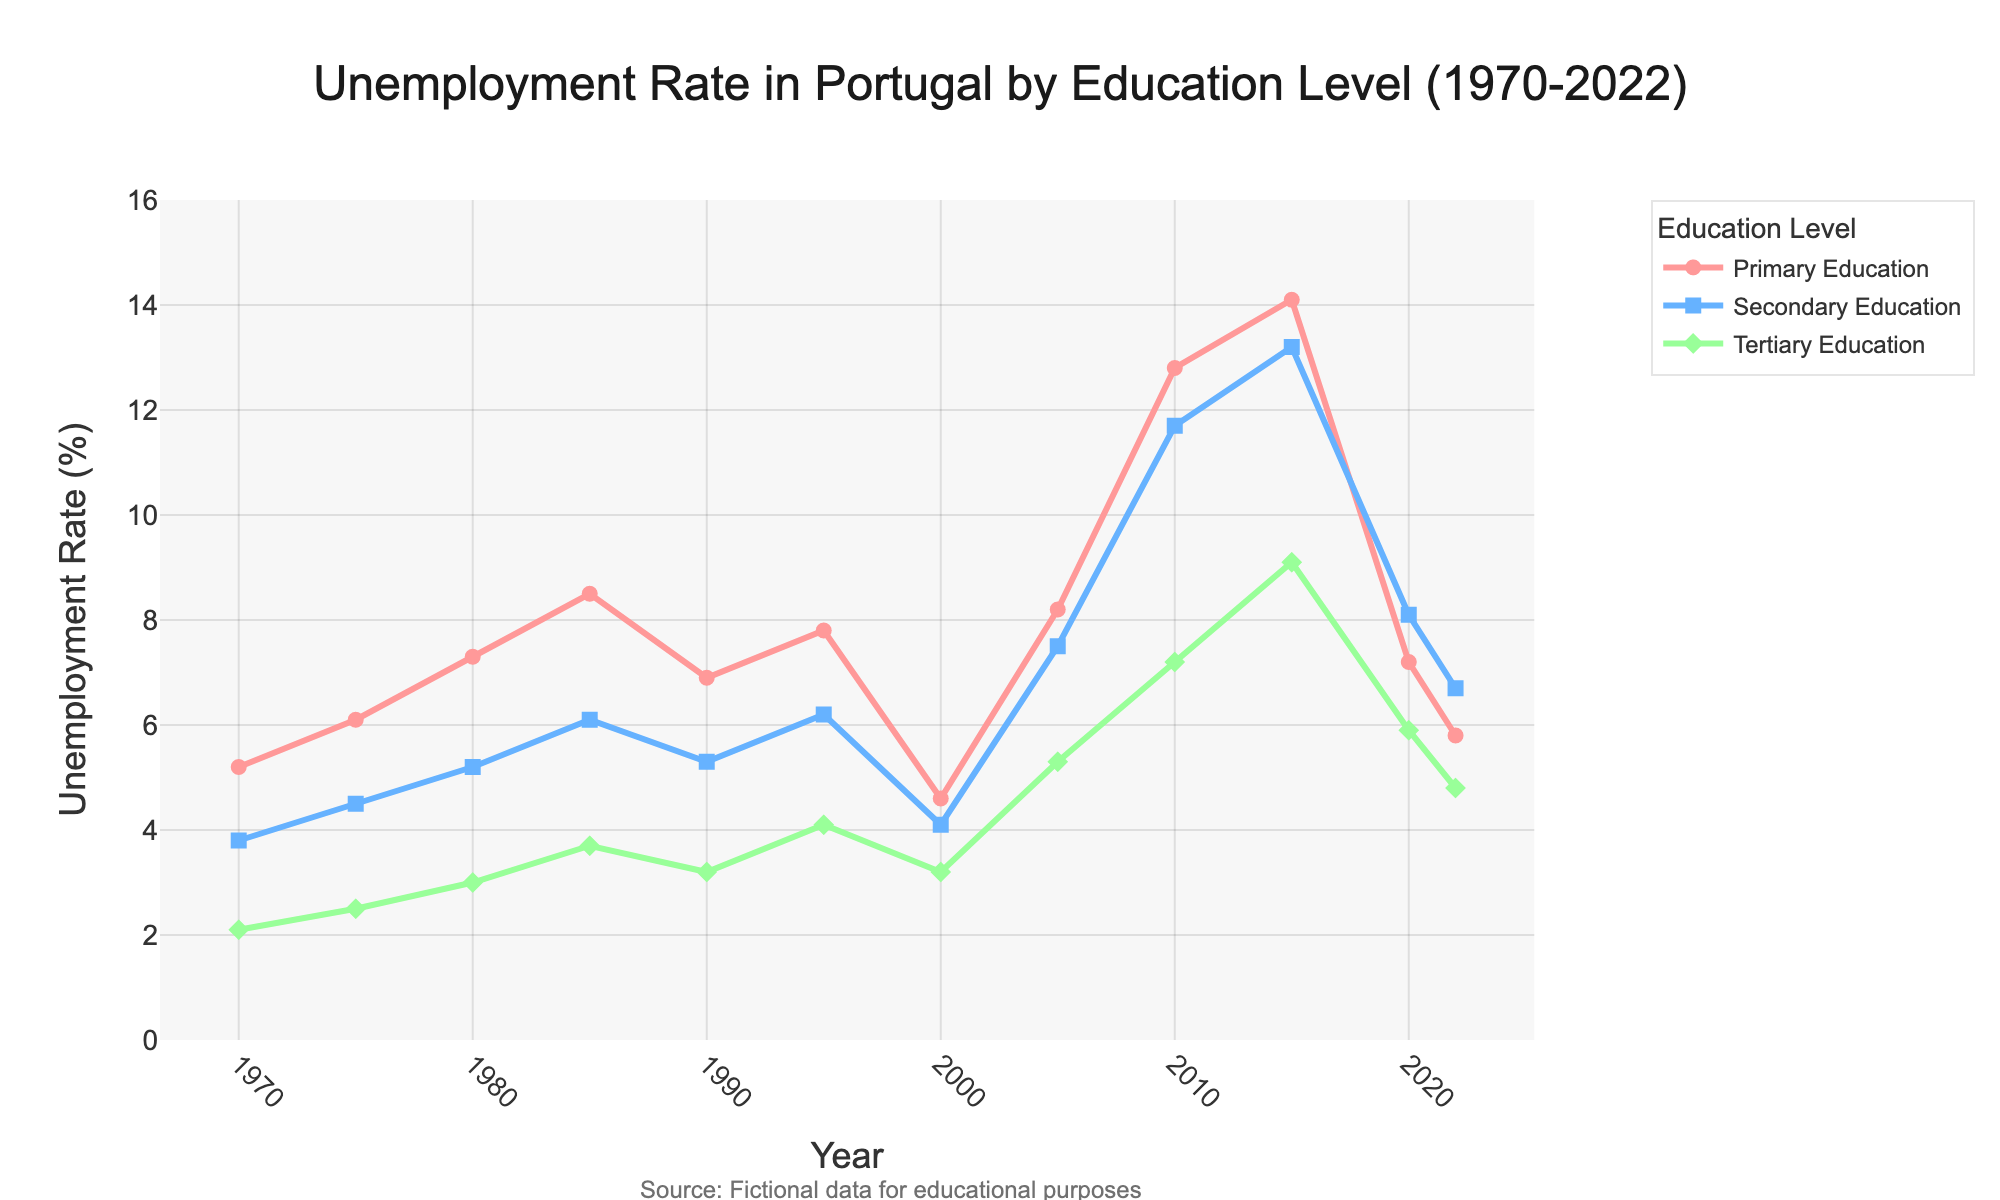What's the unemployment rate for people with primary education in 2010? Look at the line representing primary education in 2010. The value at that point is 12.8%.
Answer: 12.8% Which education level had the highest unemployment rate in 2022? Compare the unemployment rates for all three education levels in 2022. Primary education: 5.8%, Secondary education: 6.7%, Tertiary education: 4.8%. The highest is secondary education.
Answer: Secondary education During which year did the unemployment rate for secondary education surpass both primary and tertiary education? Examine the plot to identify the year when the line for secondary education goes above both primary and tertiary education lines. This occurs in 2015.
Answer: 2015 What's the difference in the unemployment rate between primary and secondary education in 2015? For 2015, note the unemployment rates: primary education: 14.1%, secondary education: 13.2%. The difference is 14.1 - 13.2.
Answer: 0.9% What was the trend in the unemployment rate for tertiary education from 2005 to 2015? Observe the slope of the line for tertiary education from 2005 to 2015. The unemployment rate increased over this period from 2005 (5.3%) to 2015 (9.1%).
Answer: Increased How did the unemployment rate for primary education change between 2000 and 2010? Compare the unemployment rates in 2000 (4.6%) and 2010 (12.8%) for primary education. The figure shows a sharp increase over this period.
Answer: Increased Which education level saw the highest peak in unemployment rate over the 50 years? Identify the highest point on the graph for each education level. Primary education peaked at 14.1% in 2015; secondary education peaked at 13.2% in 2015; tertiary education peaked at 9.1% in 2015. The highest peak overall is for primary education at 14.1%.
Answer: Primary education What was the average unemployment rate for tertiary education from 2010 to 2022? Calculate the average value for tertiary education unemployment rates in 2010 (7.2%), 2015 (9.1%), 2020 (5.9%), and 2022 (4.8%). Sum these values (7.2 + 9.1 + 5.9 + 4.8 = 27) and divide by 4 years.
Answer: 6.75% In which year did the unemployment rate for secondary education see a notable increase? Look at the secondary education line for any sharp upward slopes. The sharpest increase appears between 2005 (7.5%) and 2010 (11.7%).
Answer: 2010 Which education level had the most stable unemployment rate from 1970 to 2022? Examine the lines for which one shows the least fluctuation over time. The tertiary education rate seems the most stable compared to primary and secondary education.
Answer: Tertiary education 